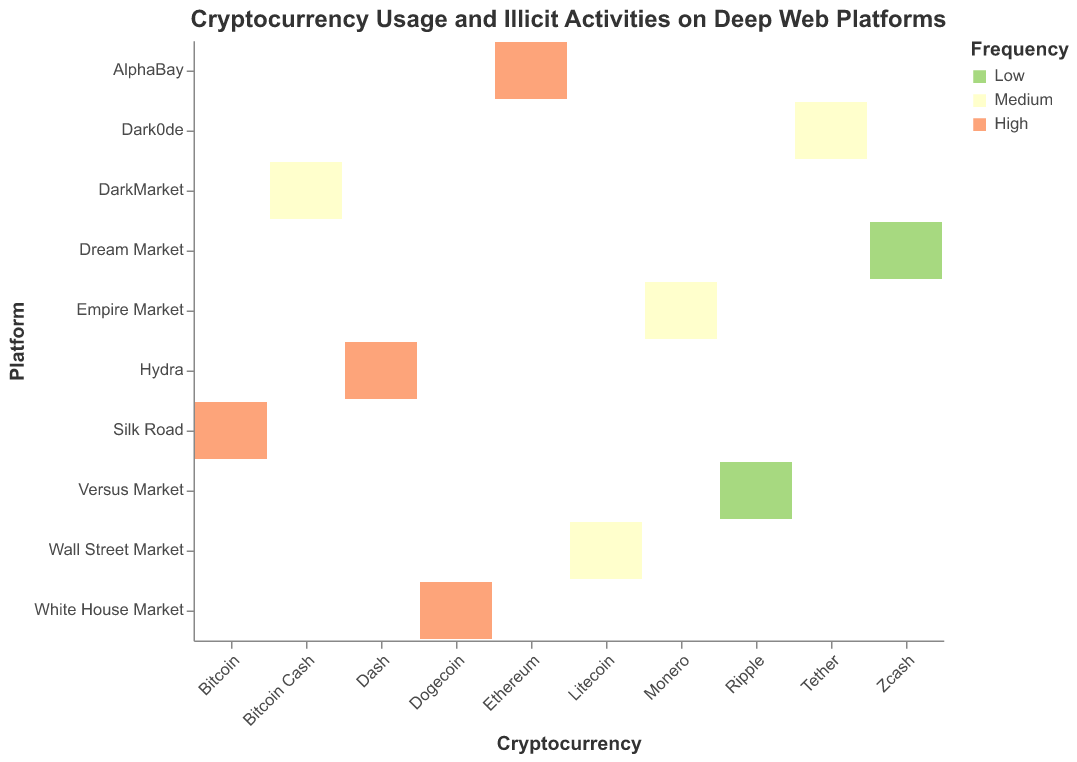What activity is associated with Bitcoin on the Silk Road platform? The visual chart identifies that Bitcoin on the Silk Road platform is associated with Drug Trafficking based on the intersection of the two axes labeled as "Cryptocurrency" and "Platform" and the data points.
Answer: Drug Trafficking Which cryptocurrency is used the most frequently for ransomware activities? By looking at the intersection of the "Cryptocurrency" and "Platform" where the activity mentions Ransomware with high frequency, it is evident that Dogecoin is the most frequently used.
Answer: Dogecoin How many cryptocurrencies are used for malware distribution on deep web platforms? The activity "Malware Distribution" appears only once in the plotted chart under the cryptocurrency "Dash" on the Hydra platform. Therefore, only one cryptocurrency is used for this activity.
Answer: 1 Which activity has the highest frequency on the AlphaBay platform? The intersection of the AlphaBay platform and its corresponding activities reveals that "Hacking Services" is marked as high frequency.
Answer: Hacking Services Compare the frequency of Identity Theft to Counterfeit Goods on their respective platforms. Identity Theft on DarkMarket (Bitcoin Cash) and Counterfeit Goods on Versus Market (Ripple) can be compared by looking at the frequency markings. Identity Theft is medium while Counterfeit Goods is low.
Answer: Identity Theft has higher frequency Which platform involves high-frequency Drug Trafficking? By checking the frequencies associated with activities, the plot indicates that the Silk Road platform involves high-frequency Drug Trafficking.
Answer: Silk Road Identify two activities that have medium frequency on their respective deep web platforms. Two activities with medium frequency can be identified: "Weapons Trade" on Empire Market (Monero) and "Data Breaches" on Dark0de (Tether).
Answer: Weapons Trade, Data Breaches What is the most common activity linked to high-frequency transactions on the deep web platforms? Observing the colored areas in the plot, high frequency is often linked with multiple activities such as Drug Trafficking (Bitcoin), Hacking Services (Ethereum), Malware Distribution (Dash), and Ransomware (Dogecoin).
Answer: Drug Trafficking, Hacking Services, Malware Distribution, Ransomware Which deep web platform is associated with Fraud, and what is its frequency? The chart shows that Wall Street Market is associated with Fraud under the cryptocurrency Litecoin, which has a medium frequency marking.
Answer: Wall Street Market, Medium 